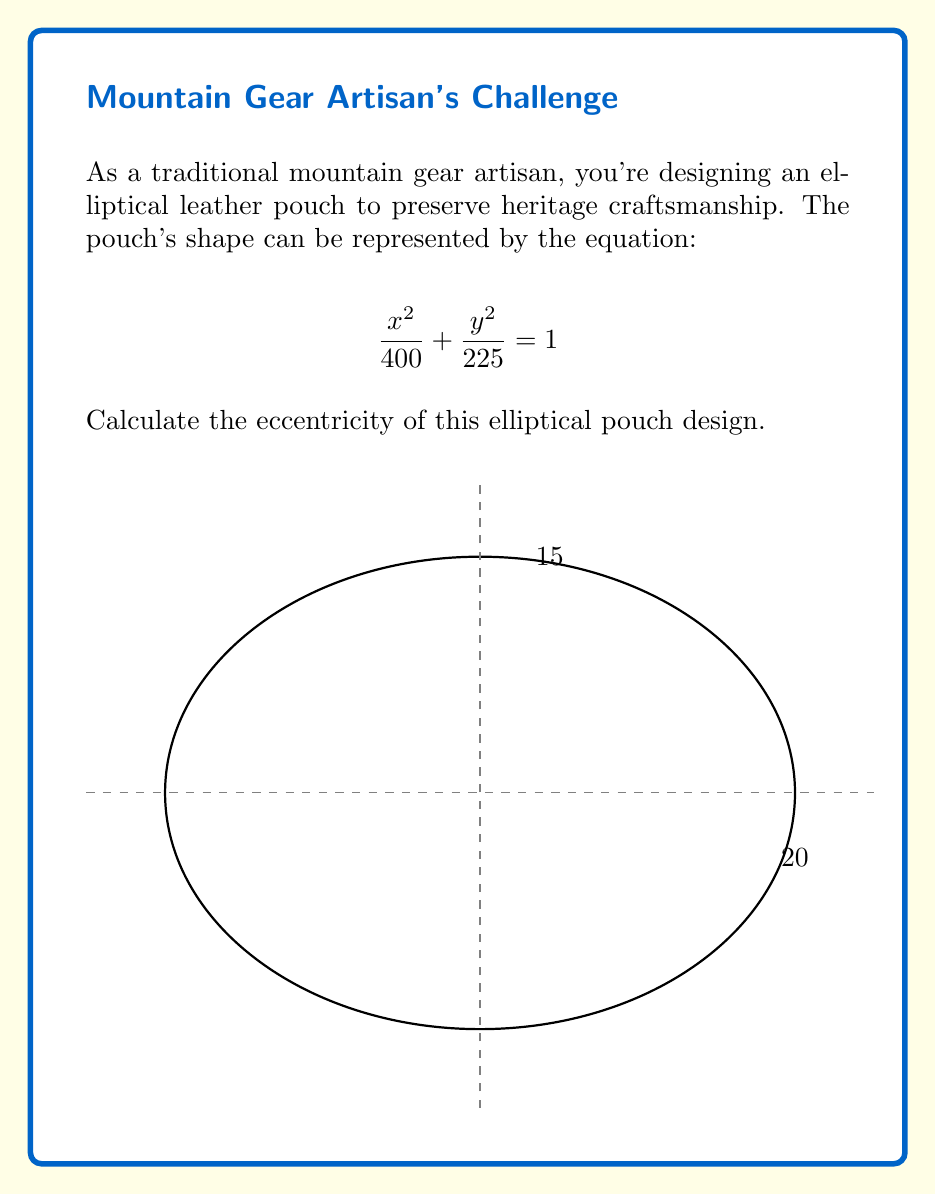Can you solve this math problem? To find the eccentricity of the ellipse, we'll follow these steps:

1) The general form of an ellipse equation is:

   $$\frac{x^2}{a^2} + \frac{y^2}{b^2} = 1$$

   where $a$ is the length of the semi-major axis and $b$ is the length of the semi-minor axis.

2) From our equation $\frac{x^2}{400} + \frac{y^2}{225} = 1$, we can deduce:
   
   $a^2 = 400$ and $b^2 = 225$

3) Therefore:
   
   $a = \sqrt{400} = 20$ and $b = \sqrt{225} = 15$

4) The eccentricity ($e$) of an ellipse is given by the formula:

   $$e = \sqrt{1 - \frac{b^2}{a^2}}$$

5) Substituting our values:

   $$e = \sqrt{1 - \frac{15^2}{20^2}}$$

6) Simplify:

   $$e = \sqrt{1 - \frac{225}{400}} = \sqrt{1 - 0.5625} = \sqrt{0.4375}$$

7) Calculate the final value:

   $$e = 0.6614$$

Therefore, the eccentricity of the elliptical pouch design is approximately 0.6614.
Answer: $e \approx 0.6614$ 